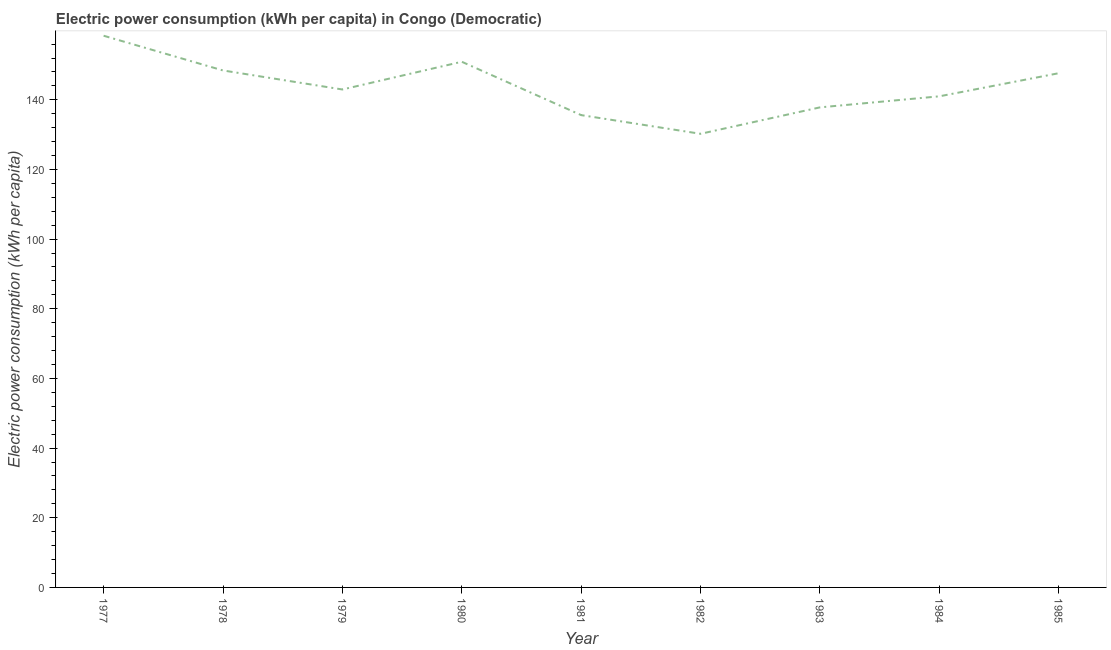What is the electric power consumption in 1977?
Offer a terse response. 158.4. Across all years, what is the maximum electric power consumption?
Your response must be concise. 158.4. Across all years, what is the minimum electric power consumption?
Make the answer very short. 130.24. What is the sum of the electric power consumption?
Provide a short and direct response. 1293.03. What is the difference between the electric power consumption in 1981 and 1982?
Provide a short and direct response. 5.37. What is the average electric power consumption per year?
Ensure brevity in your answer.  143.67. What is the median electric power consumption?
Provide a short and direct response. 142.97. Do a majority of the years between 1979 and 1978 (inclusive) have electric power consumption greater than 120 kWh per capita?
Give a very brief answer. No. What is the ratio of the electric power consumption in 1978 to that in 1981?
Provide a short and direct response. 1.09. Is the difference between the electric power consumption in 1979 and 1984 greater than the difference between any two years?
Your answer should be very brief. No. What is the difference between the highest and the second highest electric power consumption?
Keep it short and to the point. 7.47. What is the difference between the highest and the lowest electric power consumption?
Ensure brevity in your answer.  28.16. Does the electric power consumption monotonically increase over the years?
Your response must be concise. No. How many years are there in the graph?
Offer a terse response. 9. Are the values on the major ticks of Y-axis written in scientific E-notation?
Your answer should be compact. No. Does the graph contain grids?
Keep it short and to the point. No. What is the title of the graph?
Make the answer very short. Electric power consumption (kWh per capita) in Congo (Democratic). What is the label or title of the X-axis?
Provide a succinct answer. Year. What is the label or title of the Y-axis?
Give a very brief answer. Electric power consumption (kWh per capita). What is the Electric power consumption (kWh per capita) of 1977?
Make the answer very short. 158.4. What is the Electric power consumption (kWh per capita) of 1978?
Your response must be concise. 148.43. What is the Electric power consumption (kWh per capita) of 1979?
Keep it short and to the point. 142.97. What is the Electric power consumption (kWh per capita) in 1980?
Your response must be concise. 150.93. What is the Electric power consumption (kWh per capita) in 1981?
Offer a terse response. 135.61. What is the Electric power consumption (kWh per capita) of 1982?
Offer a very short reply. 130.24. What is the Electric power consumption (kWh per capita) of 1983?
Your answer should be very brief. 137.83. What is the Electric power consumption (kWh per capita) in 1984?
Provide a short and direct response. 141. What is the Electric power consumption (kWh per capita) in 1985?
Provide a short and direct response. 147.64. What is the difference between the Electric power consumption (kWh per capita) in 1977 and 1978?
Keep it short and to the point. 9.97. What is the difference between the Electric power consumption (kWh per capita) in 1977 and 1979?
Ensure brevity in your answer.  15.43. What is the difference between the Electric power consumption (kWh per capita) in 1977 and 1980?
Your answer should be compact. 7.47. What is the difference between the Electric power consumption (kWh per capita) in 1977 and 1981?
Your answer should be very brief. 22.79. What is the difference between the Electric power consumption (kWh per capita) in 1977 and 1982?
Offer a very short reply. 28.16. What is the difference between the Electric power consumption (kWh per capita) in 1977 and 1983?
Provide a succinct answer. 20.57. What is the difference between the Electric power consumption (kWh per capita) in 1977 and 1984?
Keep it short and to the point. 17.39. What is the difference between the Electric power consumption (kWh per capita) in 1977 and 1985?
Give a very brief answer. 10.76. What is the difference between the Electric power consumption (kWh per capita) in 1978 and 1979?
Your answer should be very brief. 5.46. What is the difference between the Electric power consumption (kWh per capita) in 1978 and 1980?
Provide a succinct answer. -2.5. What is the difference between the Electric power consumption (kWh per capita) in 1978 and 1981?
Ensure brevity in your answer.  12.82. What is the difference between the Electric power consumption (kWh per capita) in 1978 and 1982?
Your answer should be compact. 18.19. What is the difference between the Electric power consumption (kWh per capita) in 1978 and 1983?
Provide a succinct answer. 10.6. What is the difference between the Electric power consumption (kWh per capita) in 1978 and 1984?
Give a very brief answer. 7.42. What is the difference between the Electric power consumption (kWh per capita) in 1978 and 1985?
Offer a terse response. 0.79. What is the difference between the Electric power consumption (kWh per capita) in 1979 and 1980?
Provide a succinct answer. -7.96. What is the difference between the Electric power consumption (kWh per capita) in 1979 and 1981?
Keep it short and to the point. 7.36. What is the difference between the Electric power consumption (kWh per capita) in 1979 and 1982?
Keep it short and to the point. 12.73. What is the difference between the Electric power consumption (kWh per capita) in 1979 and 1983?
Make the answer very short. 5.14. What is the difference between the Electric power consumption (kWh per capita) in 1979 and 1984?
Provide a short and direct response. 1.96. What is the difference between the Electric power consumption (kWh per capita) in 1979 and 1985?
Offer a very short reply. -4.67. What is the difference between the Electric power consumption (kWh per capita) in 1980 and 1981?
Give a very brief answer. 15.32. What is the difference between the Electric power consumption (kWh per capita) in 1980 and 1982?
Provide a short and direct response. 20.69. What is the difference between the Electric power consumption (kWh per capita) in 1980 and 1983?
Your answer should be compact. 13.1. What is the difference between the Electric power consumption (kWh per capita) in 1980 and 1984?
Keep it short and to the point. 9.92. What is the difference between the Electric power consumption (kWh per capita) in 1980 and 1985?
Provide a short and direct response. 3.29. What is the difference between the Electric power consumption (kWh per capita) in 1981 and 1982?
Ensure brevity in your answer.  5.37. What is the difference between the Electric power consumption (kWh per capita) in 1981 and 1983?
Your answer should be compact. -2.22. What is the difference between the Electric power consumption (kWh per capita) in 1981 and 1984?
Give a very brief answer. -5.4. What is the difference between the Electric power consumption (kWh per capita) in 1981 and 1985?
Your answer should be compact. -12.03. What is the difference between the Electric power consumption (kWh per capita) in 1982 and 1983?
Provide a succinct answer. -7.59. What is the difference between the Electric power consumption (kWh per capita) in 1982 and 1984?
Offer a very short reply. -10.76. What is the difference between the Electric power consumption (kWh per capita) in 1982 and 1985?
Offer a terse response. -17.4. What is the difference between the Electric power consumption (kWh per capita) in 1983 and 1984?
Provide a succinct answer. -3.17. What is the difference between the Electric power consumption (kWh per capita) in 1983 and 1985?
Give a very brief answer. -9.81. What is the difference between the Electric power consumption (kWh per capita) in 1984 and 1985?
Provide a succinct answer. -6.63. What is the ratio of the Electric power consumption (kWh per capita) in 1977 to that in 1978?
Your answer should be compact. 1.07. What is the ratio of the Electric power consumption (kWh per capita) in 1977 to that in 1979?
Your answer should be compact. 1.11. What is the ratio of the Electric power consumption (kWh per capita) in 1977 to that in 1981?
Offer a terse response. 1.17. What is the ratio of the Electric power consumption (kWh per capita) in 1977 to that in 1982?
Keep it short and to the point. 1.22. What is the ratio of the Electric power consumption (kWh per capita) in 1977 to that in 1983?
Keep it short and to the point. 1.15. What is the ratio of the Electric power consumption (kWh per capita) in 1977 to that in 1984?
Ensure brevity in your answer.  1.12. What is the ratio of the Electric power consumption (kWh per capita) in 1977 to that in 1985?
Ensure brevity in your answer.  1.07. What is the ratio of the Electric power consumption (kWh per capita) in 1978 to that in 1979?
Ensure brevity in your answer.  1.04. What is the ratio of the Electric power consumption (kWh per capita) in 1978 to that in 1981?
Your response must be concise. 1.09. What is the ratio of the Electric power consumption (kWh per capita) in 1978 to that in 1982?
Your answer should be compact. 1.14. What is the ratio of the Electric power consumption (kWh per capita) in 1978 to that in 1983?
Ensure brevity in your answer.  1.08. What is the ratio of the Electric power consumption (kWh per capita) in 1978 to that in 1984?
Give a very brief answer. 1.05. What is the ratio of the Electric power consumption (kWh per capita) in 1978 to that in 1985?
Offer a very short reply. 1. What is the ratio of the Electric power consumption (kWh per capita) in 1979 to that in 1980?
Your answer should be compact. 0.95. What is the ratio of the Electric power consumption (kWh per capita) in 1979 to that in 1981?
Offer a terse response. 1.05. What is the ratio of the Electric power consumption (kWh per capita) in 1979 to that in 1982?
Your response must be concise. 1.1. What is the ratio of the Electric power consumption (kWh per capita) in 1979 to that in 1985?
Make the answer very short. 0.97. What is the ratio of the Electric power consumption (kWh per capita) in 1980 to that in 1981?
Ensure brevity in your answer.  1.11. What is the ratio of the Electric power consumption (kWh per capita) in 1980 to that in 1982?
Give a very brief answer. 1.16. What is the ratio of the Electric power consumption (kWh per capita) in 1980 to that in 1983?
Offer a very short reply. 1.09. What is the ratio of the Electric power consumption (kWh per capita) in 1980 to that in 1984?
Provide a short and direct response. 1.07. What is the ratio of the Electric power consumption (kWh per capita) in 1980 to that in 1985?
Provide a succinct answer. 1.02. What is the ratio of the Electric power consumption (kWh per capita) in 1981 to that in 1982?
Ensure brevity in your answer.  1.04. What is the ratio of the Electric power consumption (kWh per capita) in 1981 to that in 1985?
Your answer should be very brief. 0.92. What is the ratio of the Electric power consumption (kWh per capita) in 1982 to that in 1983?
Your answer should be very brief. 0.94. What is the ratio of the Electric power consumption (kWh per capita) in 1982 to that in 1984?
Provide a short and direct response. 0.92. What is the ratio of the Electric power consumption (kWh per capita) in 1982 to that in 1985?
Ensure brevity in your answer.  0.88. What is the ratio of the Electric power consumption (kWh per capita) in 1983 to that in 1985?
Offer a terse response. 0.93. What is the ratio of the Electric power consumption (kWh per capita) in 1984 to that in 1985?
Your response must be concise. 0.95. 